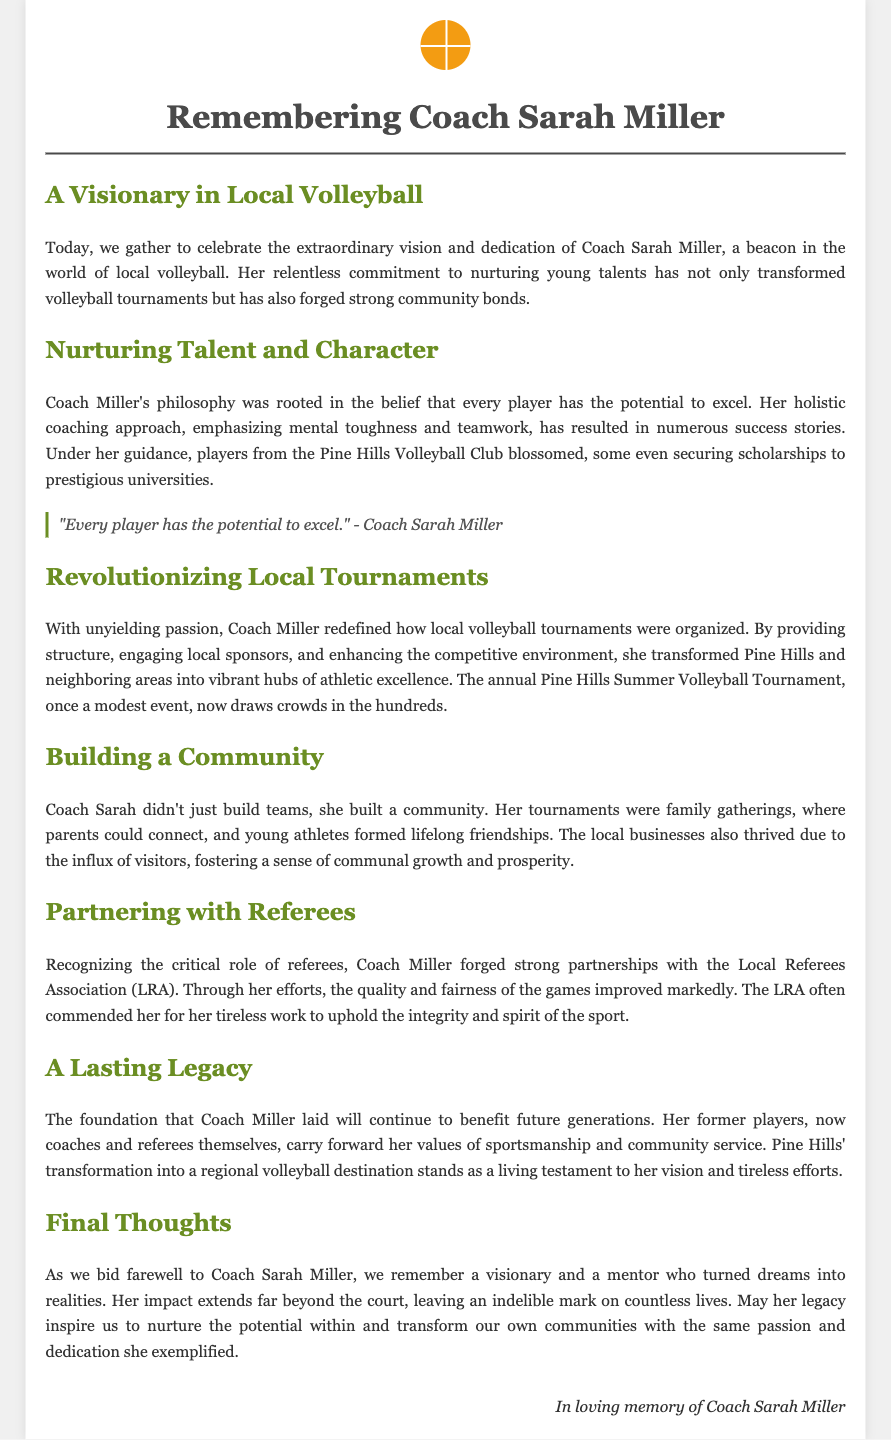What was Coach Sarah Miller's role? Coach Sarah Miller was a coach known for her vision and dedication to local volleyball.
Answer: Coach What was the name of the tournament that Coach Miller transformed? The name of the tournament that Coach Miller transformed is the Pine Hills Summer Volleyball Tournament.
Answer: Pine Hills Summer Volleyball Tournament What quote is attributed to Coach Sarah Miller? The quote attributed to Coach Sarah Miller is about every player's potential to excel.
Answer: "Every player has the potential to excel." What organization did Coach Miller partner with for referees? Coach Miller partnered with the Local Referees Association.
Answer: Local Referees Association What impact did the tournaments have on local businesses? The tournaments led to an influx of visitors, fostering a sense of communal growth and prosperity.
Answer: Thrived How did Coach Miller's coaching philosophy influence players? Her coaching philosophy emphasized mental toughness and teamwork, resulting in numerous success stories.
Answer: Success stories What legacy did Coach Miller leave behind? Coach Miller's legacy includes her former players, who are now coaches and referees.
Answer: Coaches and referees How did the crowds at the tournaments change over time? The crowds at the tournaments grew from modest beginnings to hundreds of attendees.
Answer: Hundreds In what ways did Coach Miller build a sense of community? Coach Miller's tournaments acted as family gatherings where connections and friendships were formed.
Answer: Family gatherings 